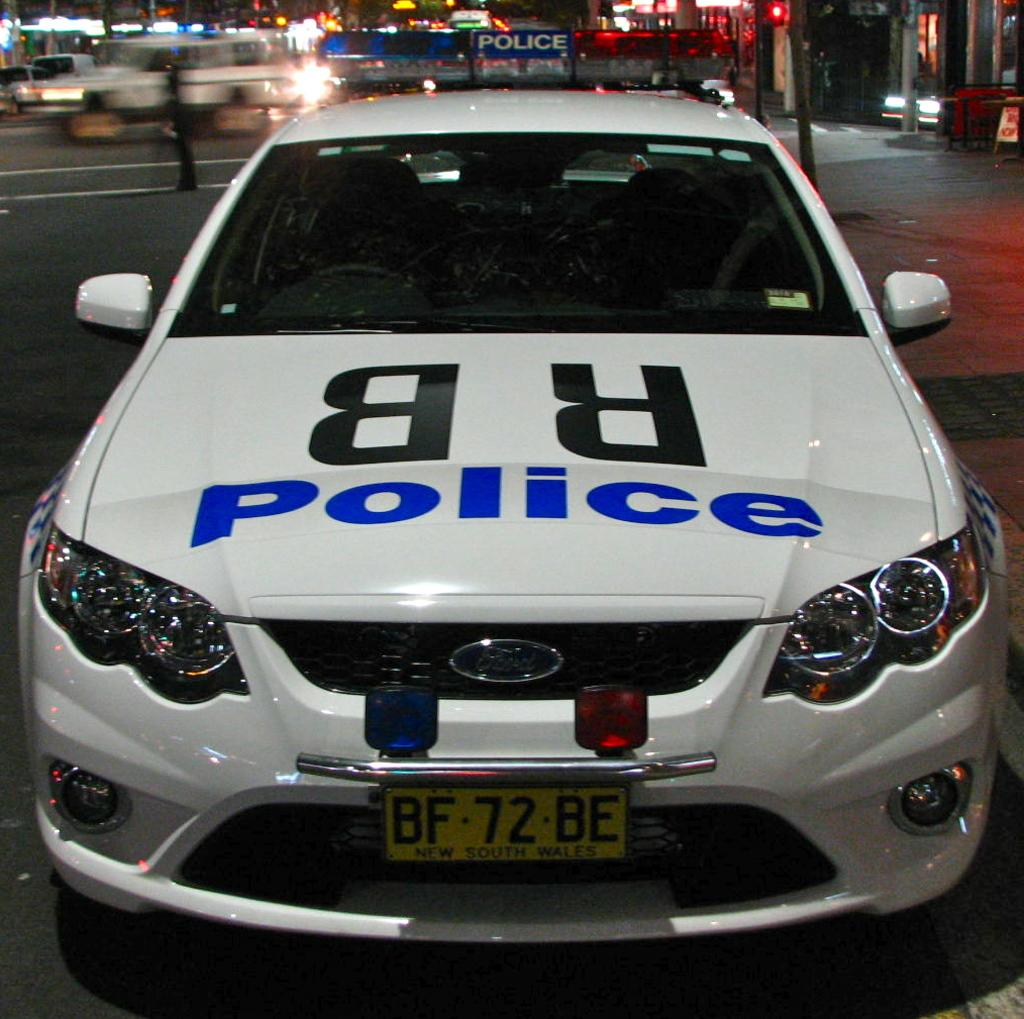What is happening on the road in the image? There are vehicles on the road in the image. Can you describe one of the vehicles? One of the vehicles is white. What can be seen in the distance behind the vehicles? There are buildings visible in the background of the image. What type of illumination is present in the image? There are lights visible in the image. How many rabbits can be seen swimming in the river in the image? There is no river or rabbits present in the image. 